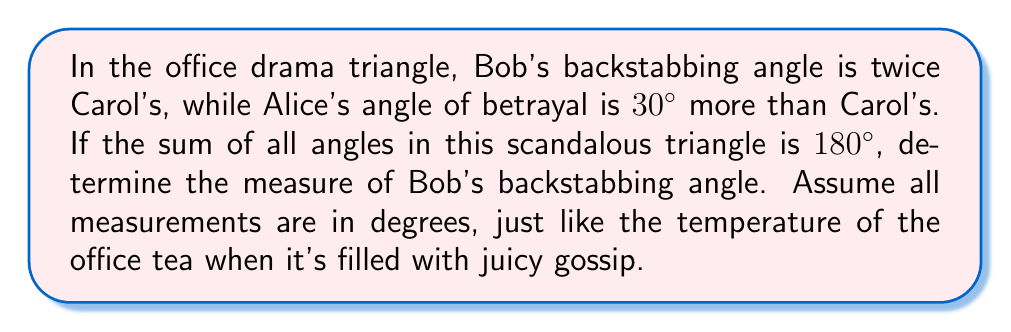Could you help me with this problem? Let's solve this step-by-step:

1) Let Carol's angle be $x°$.

2) Given information:
   - Bob's angle = $2x°$
   - Alice's angle = $(x + 30)°$
   - Sum of angles in a triangle = 180°

3) Set up the equation:
   $x° + 2x° + (x + 30)° = 180°$

4) Simplify:
   $4x° + 30° = 180°$

5) Subtract 30° from both sides:
   $4x° = 150°$

6) Divide both sides by 4:
   $x° = 37.5°$

7) Remember, we want Bob's angle, which is $2x°$:
   Bob's angle = $2 * 37.5° = 75°$

[asy]
import geometry;

pair A = (0,0), B = (100,0), C = (50,86.6);
draw(A--B--C--A);
label("Alice", A, SW);
label("Bob", B, SE);
label("Carol", C, N);
label("75°", B, NE);
[/asy]
Answer: $75°$ 